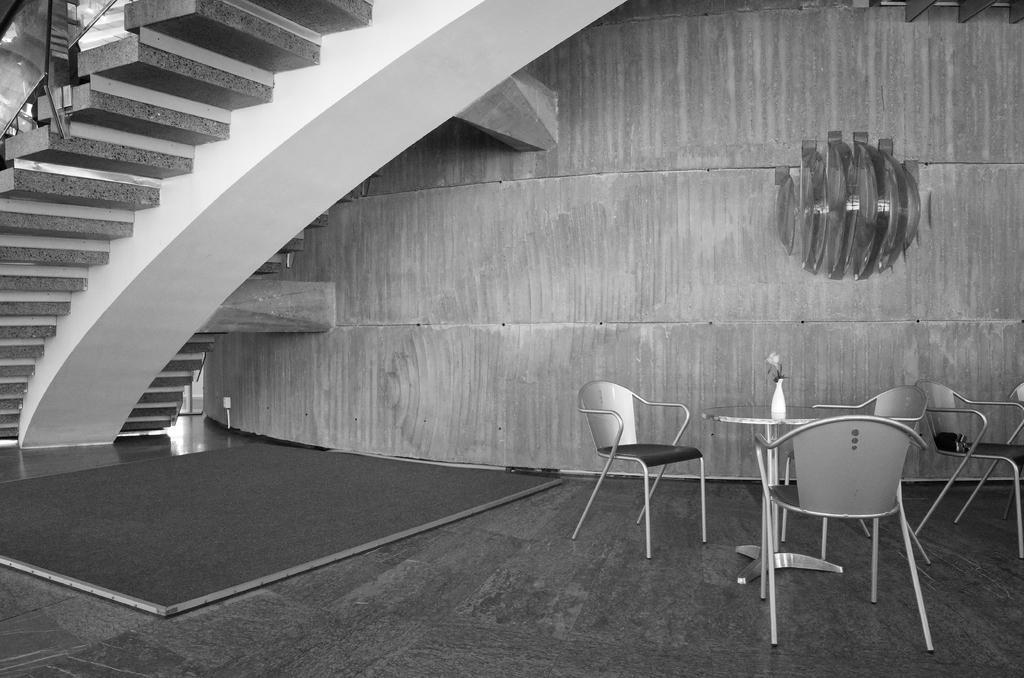In one or two sentences, can you explain what this image depicts? This is a black and white image and here we can see chairs and there is a flower vase on the table. In the background, there are stairs and we can see a stand on the wall. At the bottom, there is a board on the floor. 